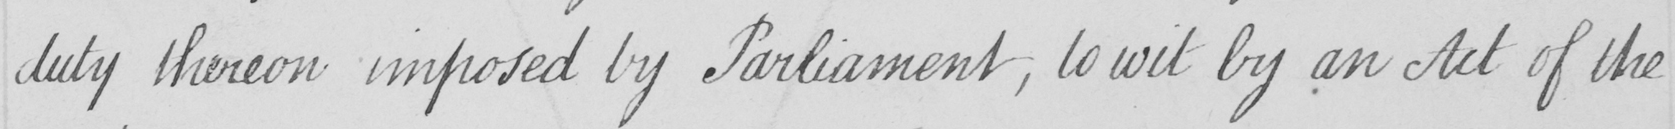Can you read and transcribe this handwriting? duty thereon imposed by Parliament , to wit by an Act of the 